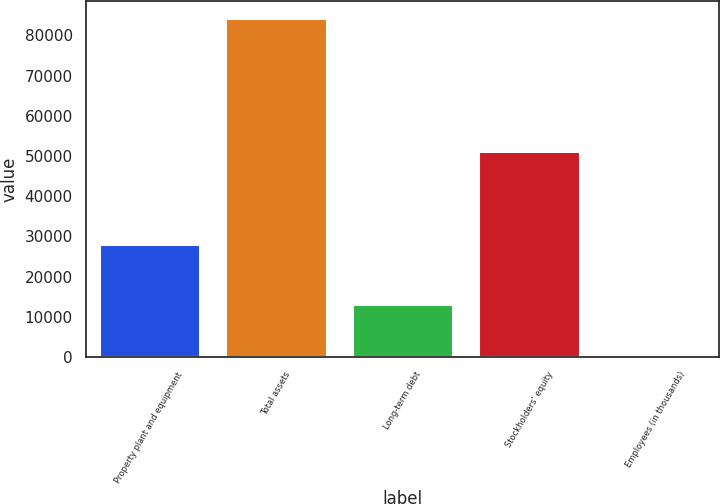Convert chart. <chart><loc_0><loc_0><loc_500><loc_500><bar_chart><fcel>Property plant and equipment<fcel>Total assets<fcel>Long-term debt<fcel>Stockholders' equity<fcel>Employees (in thousands)<nl><fcel>27983<fcel>84351<fcel>13136<fcel>51203<fcel>105<nl></chart> 